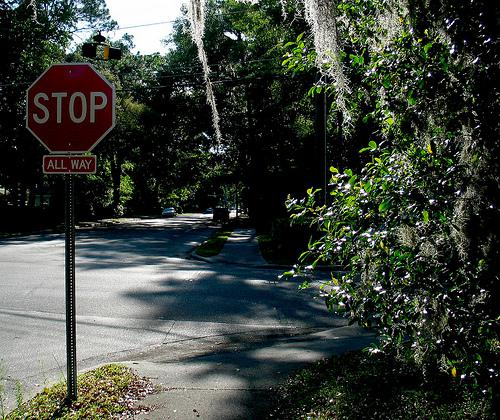Question: why is the sign there?
Choices:
A. To let people know the road is closed.
B. To make people stop.
C. Because the speed limit drops.
D. To keep people from parking there.
Answer with the letter. Answer: B Question: what is hanging in the tree?
Choices:
A. A wasp's nest.
B. Spanish Moss.
C. A kite.
D. A vine.
Answer with the letter. Answer: B Question: where is the picture taken?
Choices:
A. In a garden.
B. At a museum.
C. On the roof.
D. A corner.
Answer with the letter. Answer: D Question: what is on the ground?
Choices:
A. Snow.
B. Leaves.
C. Gravel.
D. Hail.
Answer with the letter. Answer: B Question: when was the picture taken?
Choices:
A. In the day.
B. Last week.
C. At night.
D. On Christmas Day.
Answer with the letter. Answer: A 